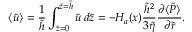<formula> <loc_0><loc_0><loc_500><loc_500>\left \langle \tilde { u } \right \rangle = \frac { 1 } { \tilde { h } } \int _ { \tilde { z } = 0 } ^ { \tilde { z } = \tilde { h } } \tilde { u } \, d \tilde { z } = - H _ { a } ( x ) \frac { \tilde { h } ^ { 2 } } { 3 \tilde { \eta } } \frac { \partial \langle \tilde { P } \rangle } { \partial \tilde { r } } .</formula> 